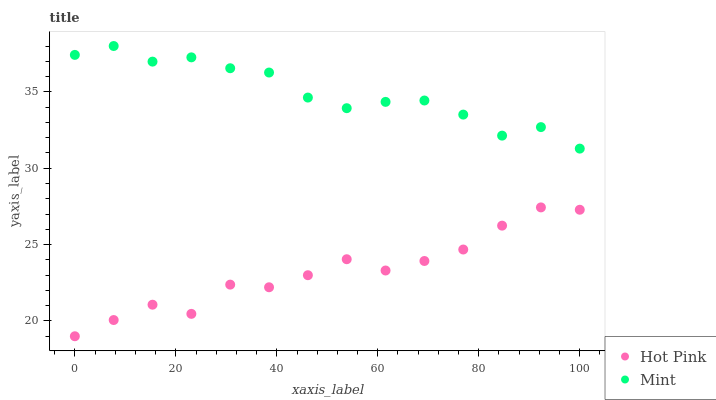Does Hot Pink have the minimum area under the curve?
Answer yes or no. Yes. Does Mint have the maximum area under the curve?
Answer yes or no. Yes. Does Mint have the minimum area under the curve?
Answer yes or no. No. Is Hot Pink the smoothest?
Answer yes or no. Yes. Is Mint the roughest?
Answer yes or no. Yes. Is Mint the smoothest?
Answer yes or no. No. Does Hot Pink have the lowest value?
Answer yes or no. Yes. Does Mint have the lowest value?
Answer yes or no. No. Does Mint have the highest value?
Answer yes or no. Yes. Is Hot Pink less than Mint?
Answer yes or no. Yes. Is Mint greater than Hot Pink?
Answer yes or no. Yes. Does Hot Pink intersect Mint?
Answer yes or no. No. 